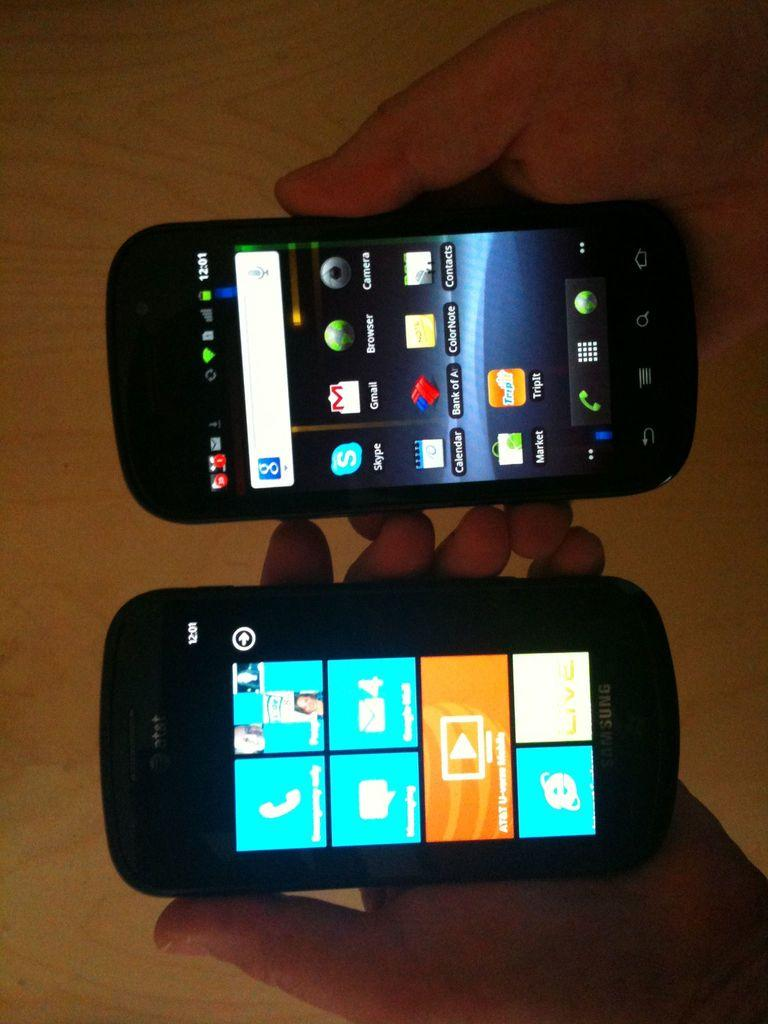<image>
Relay a brief, clear account of the picture shown. One of two black cell phones is AT&T Samsung and being held in somebody's hand. 